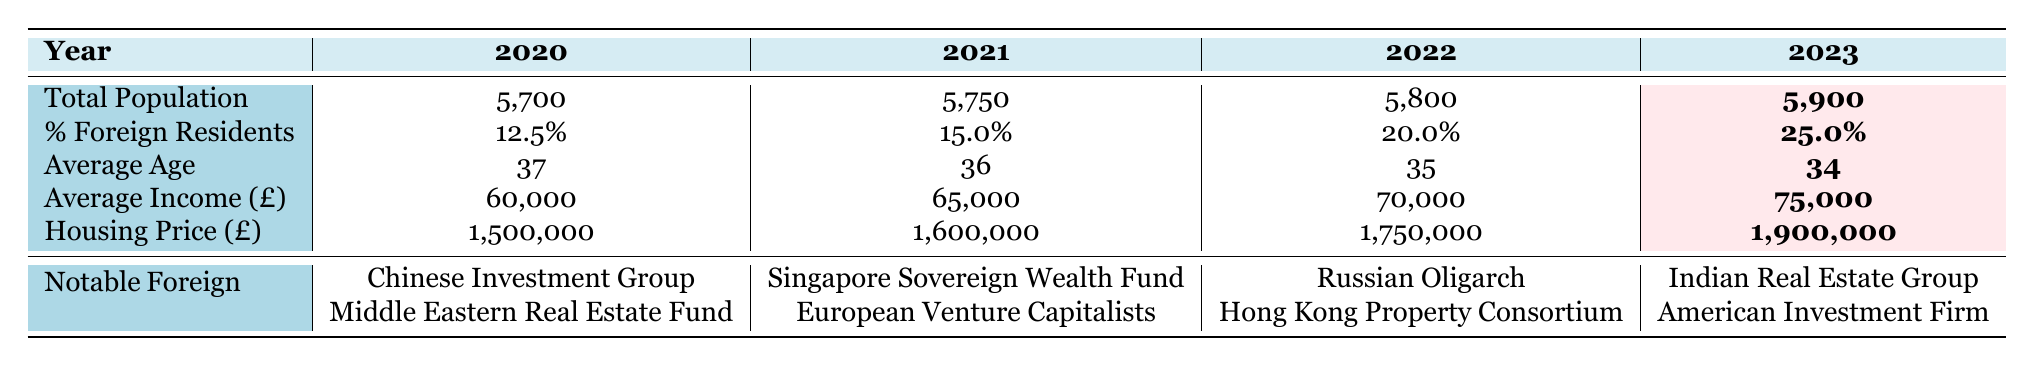What is the total population in 2023? According to the table, the total population figure for 2023 is highlighted, which shows that the total population is 5,900.
Answer: 5,900 What was the percentage of foreign residents in 2021? The table lists the percentage of foreign residents for each year, and for 2021, it is recorded as 15.0%.
Answer: 15.0% What was the average income in Mayfair in 2022? The average income for 2022 is presented in the table, and it indicates that the average income was £70,000.
Answer: £70,000 In which year was the housing price the highest? By examining the housing prices for each year, 2023, with a housing price of £1,900,000, is the highest value listed in the table.
Answer: 2023 Is the average age in Mayfair decreasing from 2020 to 2023? The average age is 37 in 2020 and decreases to 34 by 2023, showing a trend of decreasing average age over these years.
Answer: Yes What is the change in percentage of foreign residents from 2020 to 2023? The percentage of foreign residents in 2020 is 12.5%, and in 2023 it is 25.0%. So, the change is 25.0% - 12.5% = 12.5%.
Answer: 12.5% What is the average income growth from 2020 to 2023? The average income increased from £60,000 in 2020 to £75,000 in 2023. The growth is calculated as £75,000 - £60,000 = £15,000.
Answer: £15,000 Which year had the most notable foreign investors listed, and who were they? Reviewing the table, each year has notable foreign investors listed, and in 2023, they are the Indian Real Estate Group and American Investment Firm.
Answer: 2023; Indian Real Estate Group, American Investment Firm What is the total change in housing price from 2020 to 2023? The housing prices listed show a progression from £1,500,000 in 2020 to £1,900,000 in 2023. The total change is calculated as £1,900,000 - £1,500,000 = £400,000.
Answer: £400,000 In 2022, what was the average age compared to the average age in 2021? The average age in 2022 was 35, while in 2021 it was 36. Therefore, the average age decreased from 2021 to 2022.
Answer: Decreased by 1 year 